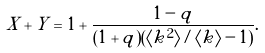<formula> <loc_0><loc_0><loc_500><loc_500>X + Y = 1 + \frac { 1 - q } { ( 1 + q ) ( \langle k ^ { 2 } \rangle / \langle k \rangle - 1 ) } .</formula> 